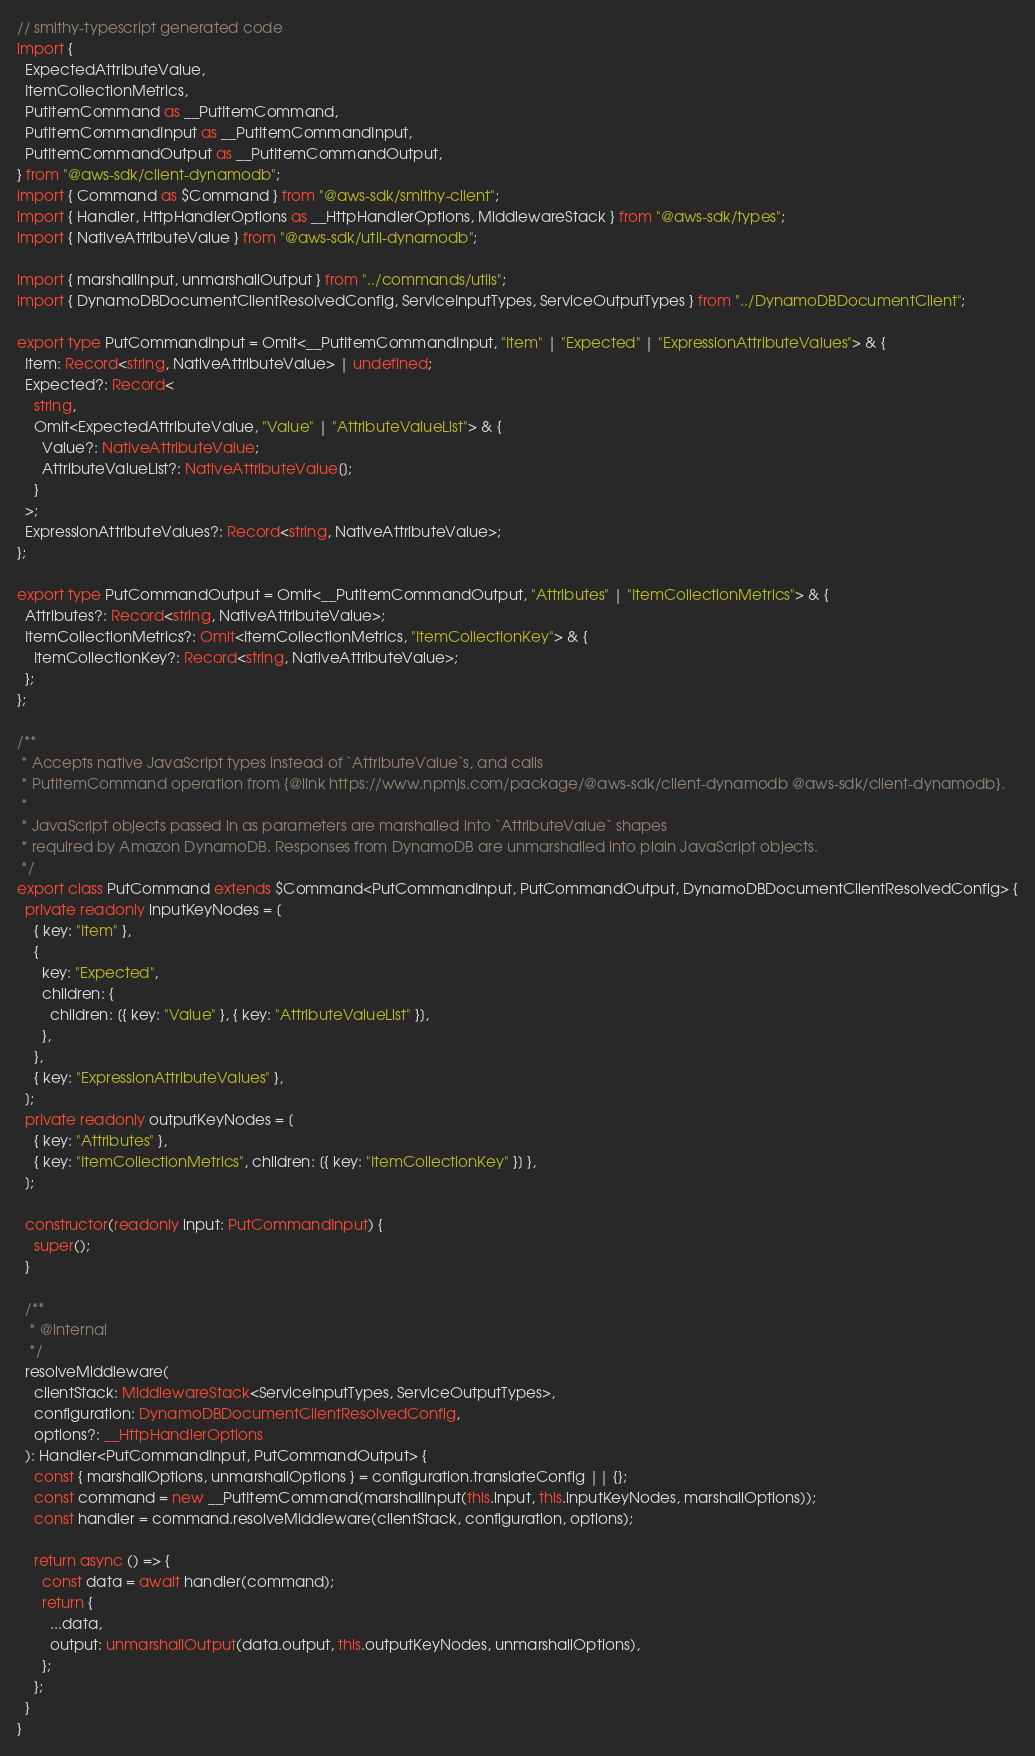Convert code to text. <code><loc_0><loc_0><loc_500><loc_500><_TypeScript_>// smithy-typescript generated code
import {
  ExpectedAttributeValue,
  ItemCollectionMetrics,
  PutItemCommand as __PutItemCommand,
  PutItemCommandInput as __PutItemCommandInput,
  PutItemCommandOutput as __PutItemCommandOutput,
} from "@aws-sdk/client-dynamodb";
import { Command as $Command } from "@aws-sdk/smithy-client";
import { Handler, HttpHandlerOptions as __HttpHandlerOptions, MiddlewareStack } from "@aws-sdk/types";
import { NativeAttributeValue } from "@aws-sdk/util-dynamodb";

import { marshallInput, unmarshallOutput } from "../commands/utils";
import { DynamoDBDocumentClientResolvedConfig, ServiceInputTypes, ServiceOutputTypes } from "../DynamoDBDocumentClient";

export type PutCommandInput = Omit<__PutItemCommandInput, "Item" | "Expected" | "ExpressionAttributeValues"> & {
  Item: Record<string, NativeAttributeValue> | undefined;
  Expected?: Record<
    string,
    Omit<ExpectedAttributeValue, "Value" | "AttributeValueList"> & {
      Value?: NativeAttributeValue;
      AttributeValueList?: NativeAttributeValue[];
    }
  >;
  ExpressionAttributeValues?: Record<string, NativeAttributeValue>;
};

export type PutCommandOutput = Omit<__PutItemCommandOutput, "Attributes" | "ItemCollectionMetrics"> & {
  Attributes?: Record<string, NativeAttributeValue>;
  ItemCollectionMetrics?: Omit<ItemCollectionMetrics, "ItemCollectionKey"> & {
    ItemCollectionKey?: Record<string, NativeAttributeValue>;
  };
};

/**
 * Accepts native JavaScript types instead of `AttributeValue`s, and calls
 * PutItemCommand operation from {@link https://www.npmjs.com/package/@aws-sdk/client-dynamodb @aws-sdk/client-dynamodb}.
 *
 * JavaScript objects passed in as parameters are marshalled into `AttributeValue` shapes
 * required by Amazon DynamoDB. Responses from DynamoDB are unmarshalled into plain JavaScript objects.
 */
export class PutCommand extends $Command<PutCommandInput, PutCommandOutput, DynamoDBDocumentClientResolvedConfig> {
  private readonly inputKeyNodes = [
    { key: "Item" },
    {
      key: "Expected",
      children: {
        children: [{ key: "Value" }, { key: "AttributeValueList" }],
      },
    },
    { key: "ExpressionAttributeValues" },
  ];
  private readonly outputKeyNodes = [
    { key: "Attributes" },
    { key: "ItemCollectionMetrics", children: [{ key: "ItemCollectionKey" }] },
  ];

  constructor(readonly input: PutCommandInput) {
    super();
  }

  /**
   * @internal
   */
  resolveMiddleware(
    clientStack: MiddlewareStack<ServiceInputTypes, ServiceOutputTypes>,
    configuration: DynamoDBDocumentClientResolvedConfig,
    options?: __HttpHandlerOptions
  ): Handler<PutCommandInput, PutCommandOutput> {
    const { marshallOptions, unmarshallOptions } = configuration.translateConfig || {};
    const command = new __PutItemCommand(marshallInput(this.input, this.inputKeyNodes, marshallOptions));
    const handler = command.resolveMiddleware(clientStack, configuration, options);

    return async () => {
      const data = await handler(command);
      return {
        ...data,
        output: unmarshallOutput(data.output, this.outputKeyNodes, unmarshallOptions),
      };
    };
  }
}
</code> 